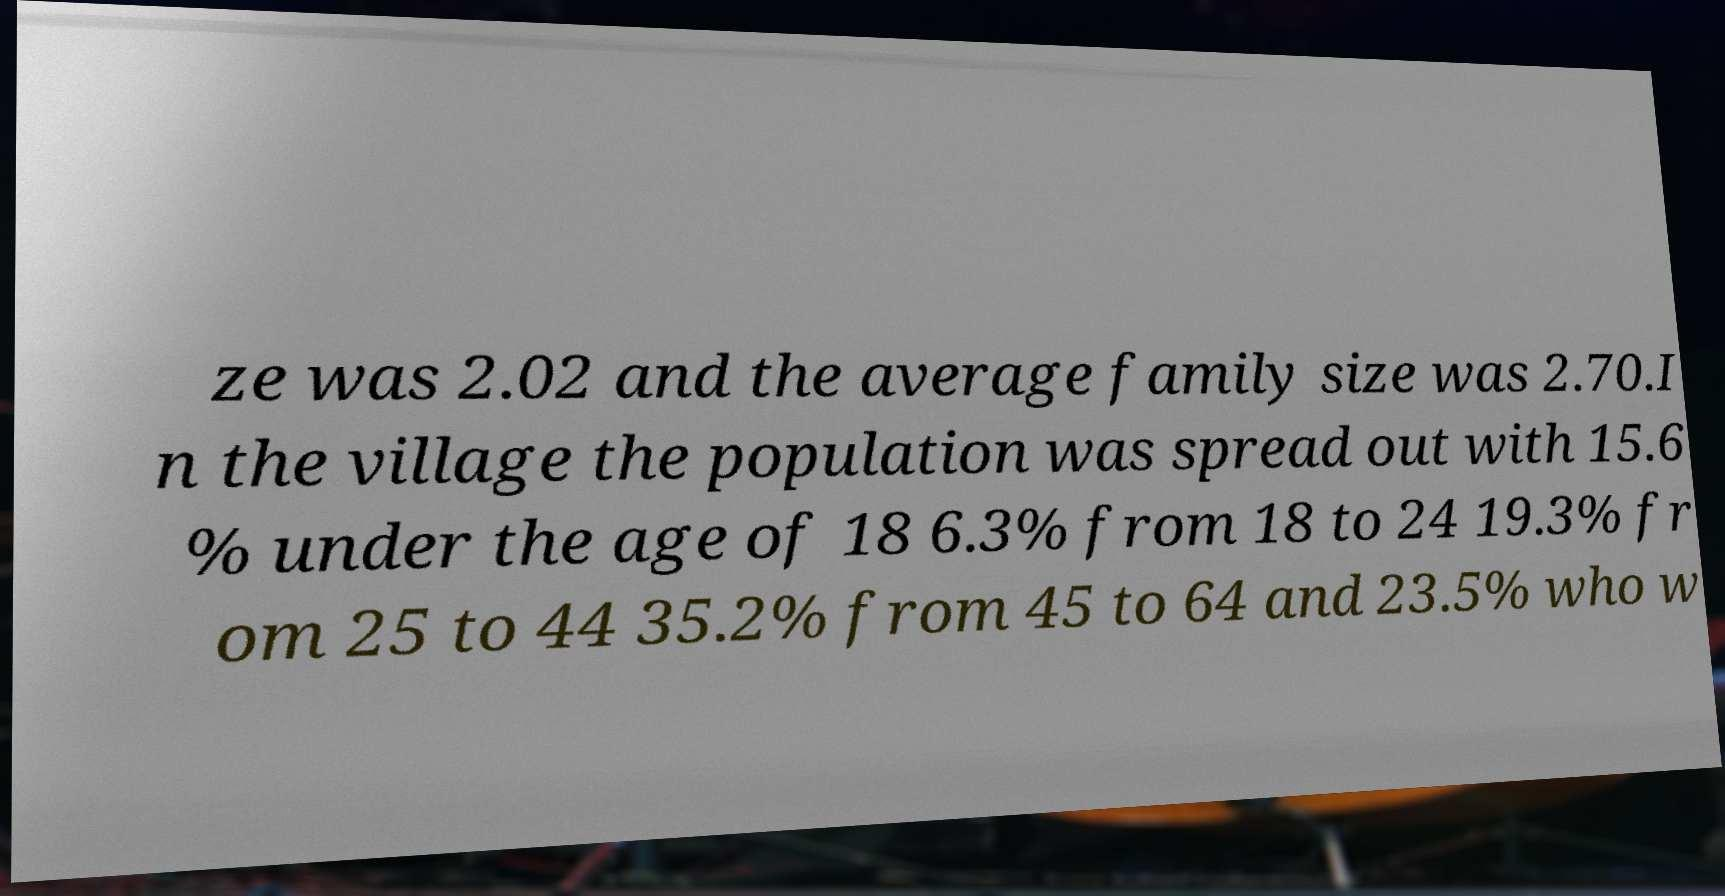Please read and relay the text visible in this image. What does it say? ze was 2.02 and the average family size was 2.70.I n the village the population was spread out with 15.6 % under the age of 18 6.3% from 18 to 24 19.3% fr om 25 to 44 35.2% from 45 to 64 and 23.5% who w 